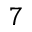<formula> <loc_0><loc_0><loc_500><loc_500>7</formula> 